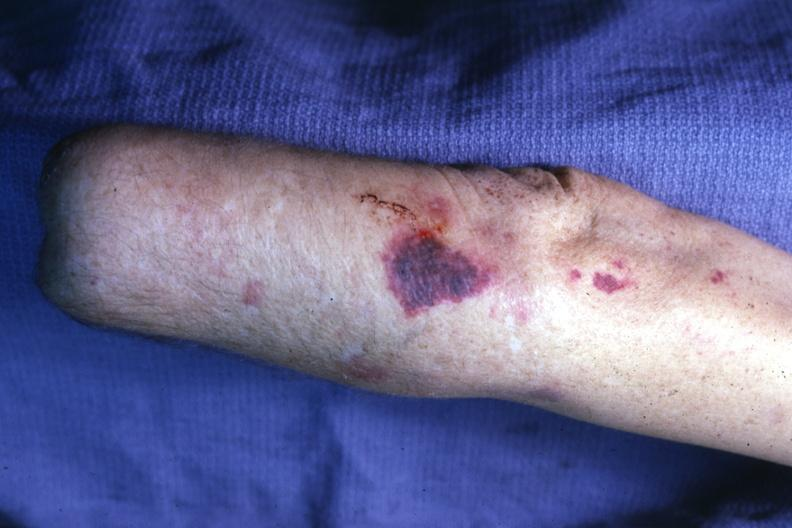what is present?
Answer the question using a single word or phrase. Ecchymosis 